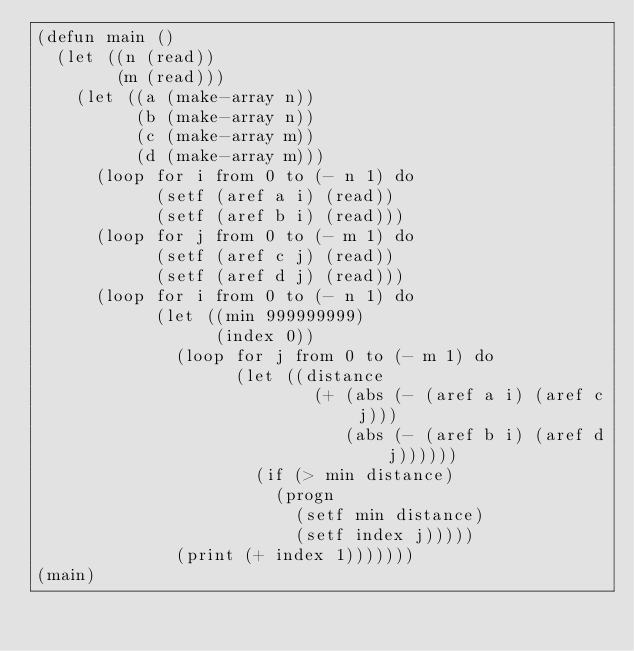Convert code to text. <code><loc_0><loc_0><loc_500><loc_500><_Lisp_>(defun main ()
  (let ((n (read))
        (m (read)))
    (let ((a (make-array n)) 
          (b (make-array n))
          (c (make-array m)) 
          (d (make-array m)))
      (loop for i from 0 to (- n 1) do
            (setf (aref a i) (read))
            (setf (aref b i) (read)))
      (loop for j from 0 to (- m 1) do
            (setf (aref c j) (read))
            (setf (aref d j) (read)))
      (loop for i from 0 to (- n 1) do
            (let ((min 999999999)
                  (index 0))
              (loop for j from 0 to (- m 1) do
                    (let ((distance 
                            (+ (abs (- (aref a i) (aref c j)))
                               (abs (- (aref b i) (aref d j))))))
                      (if (> min distance)
                        (progn 
                          (setf min distance)
                          (setf index j)))))
              (print (+ index 1)))))))
(main)
</code> 